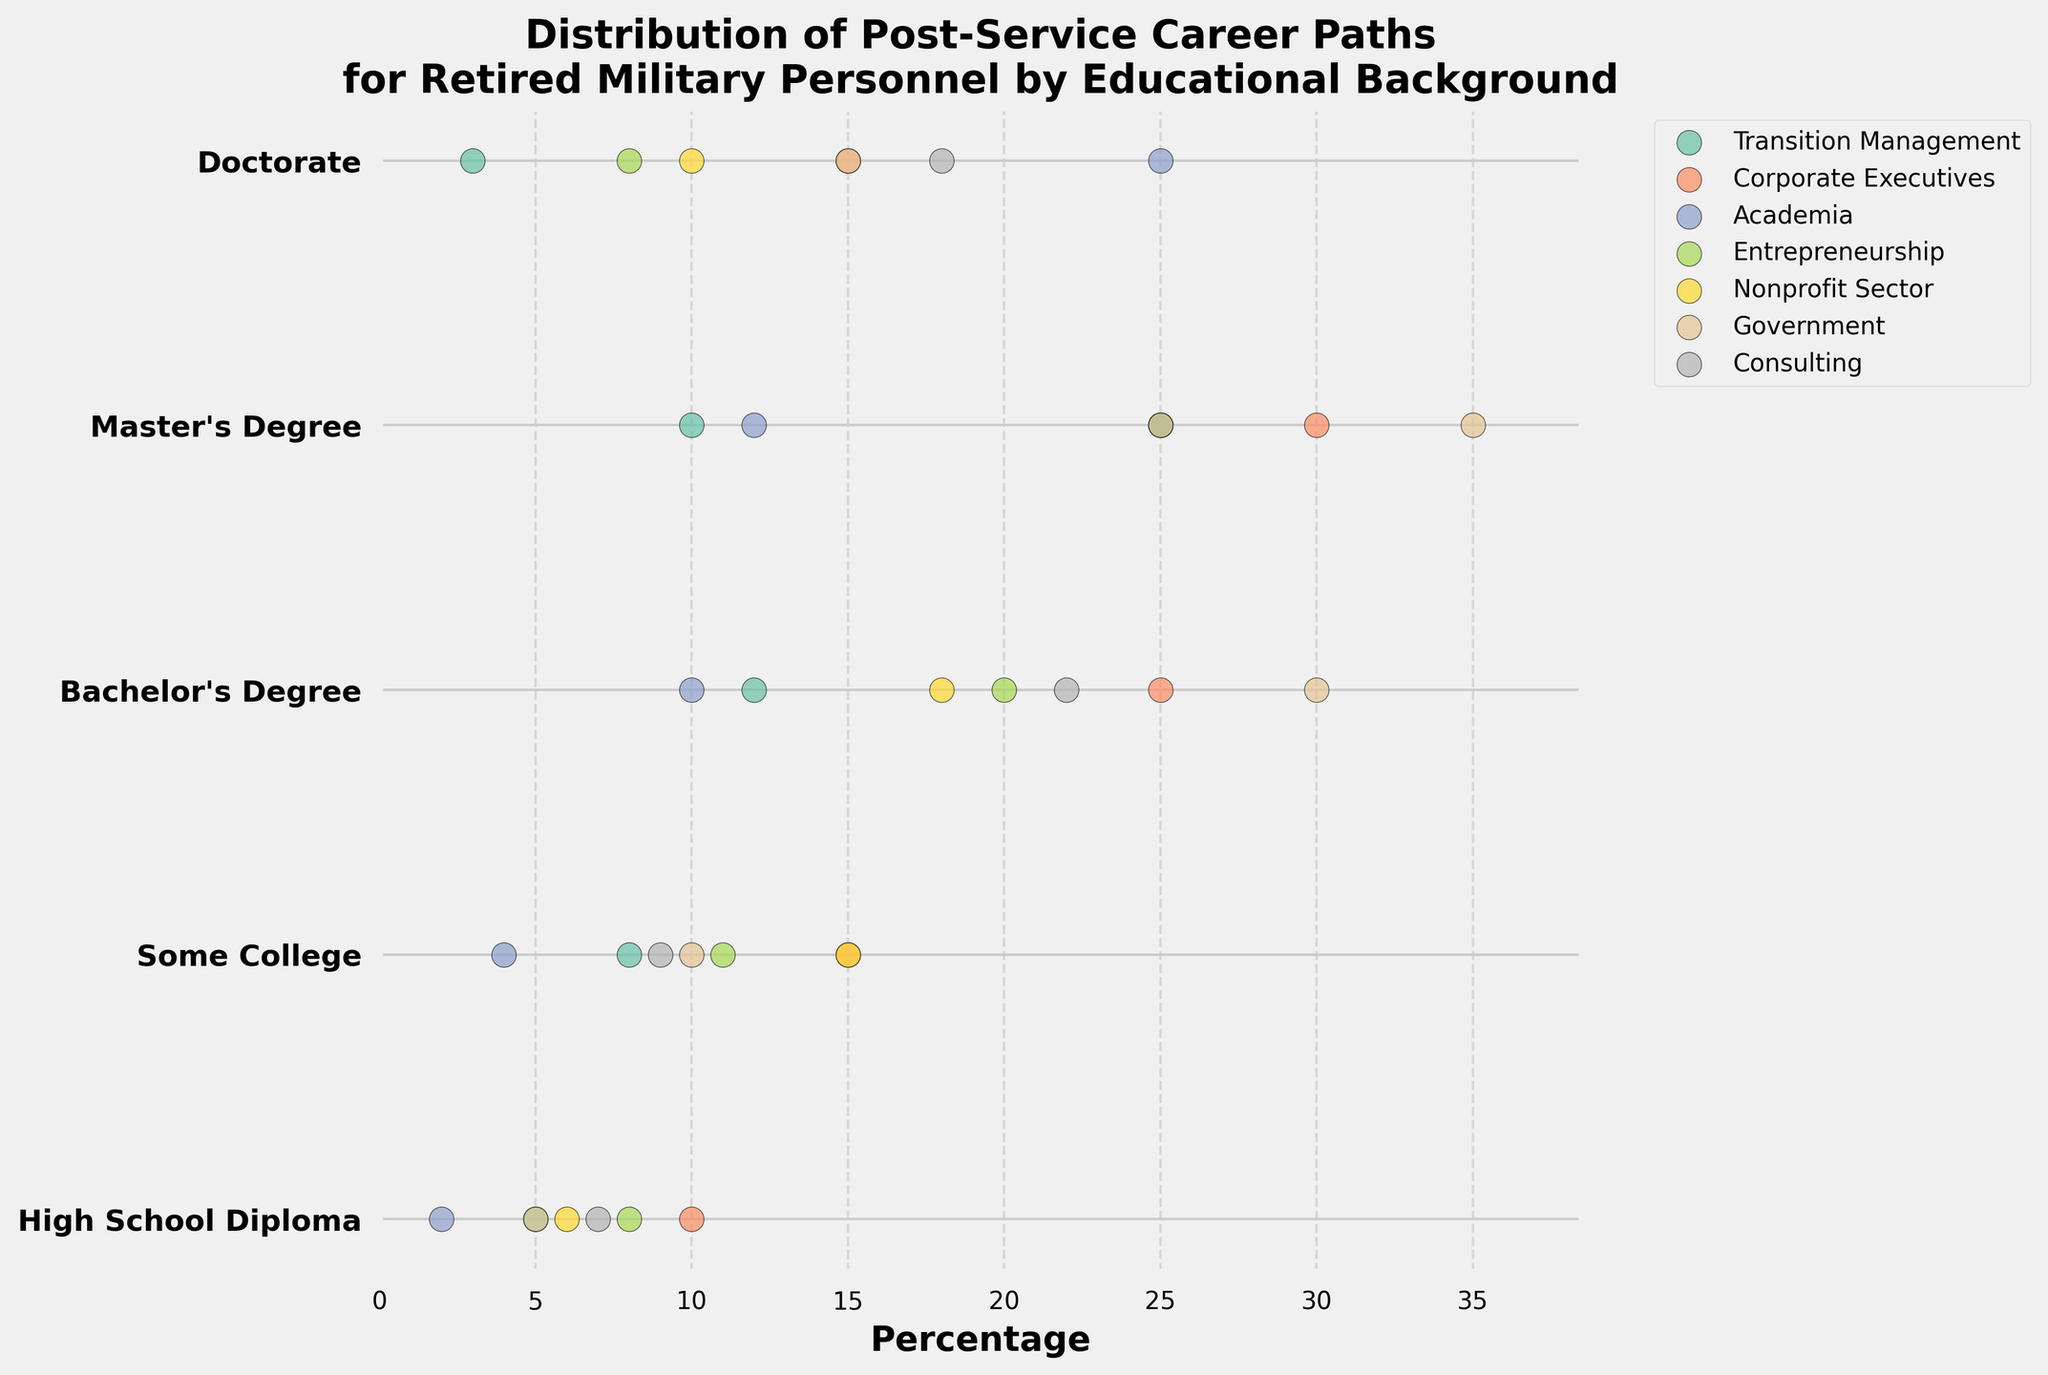What is the title of the figure? The title can be found at the top of the figure. It usually provides a succinct description of what the figure depicts.
Answer: Distribution of Post-Service Career Paths for Retired Military Personnel by Educational Background Which career path has the highest percentage for individuals with a Master’s Degree? To determine this, locate the row corresponding to "Master's Degree" and identify the career path with the highest dot in that row.
Answer: Government What is the range of percentages for the career path "Consulting" across all educational backgrounds? Identify the dots corresponding to "Consulting" and note the minimum and maximum values. The range is the difference between these values.
Answer: 7 to 25 How do the percentages of "Academia" compare between those with a Bachelor's Degree and those with a Doctorate? Find the dots corresponding to "Academia" for both "Bachelor's Degree" and "Doctorate" and compare their positions on the x-axis.
Answer: Higher for Doctorate Which educational background shows the least transition to "Corporate Executives"? Identify the row with the lowest dot for "Corporate Executives".
Answer: High School Diploma If you sum the percentages for "Entrepreneurship" for all educational backgrounds, what is the total? Add the percentages for "Entrepreneurship" from each row.
Answer: 8 + 11 + 20 + 25 + 8 = 72 Which career paths have the same percentage for individuals with Some College? Examine the row corresponding to "Some College" and identify any dots that are positioned at the same x-axis value.
Answer: Transition Management and Nonprofit Sector (both 15%) What is the average percentage for "Government" across all educational backgrounds? Calculate the mean by summing the percentages in the "Government" column and dividing by the number of educational backgrounds.
Answer: (5 + 10 + 30 + 35 + 15) / 5 = 19 Is the percentage for "Consulting" higher for those with a Bachelor's Degree or a Master's Degree? Locate the dots for "Consulting" in the rows for "Bachelor's Degree" and "Master's Degree" and compare their values.
Answer: Master's Degree Which educational background has the broadest range of career paths in terms of percentage? Look at each row and determine which one has the largest difference between the highest and lowest dot.
Answer: Bachelor's Degree 